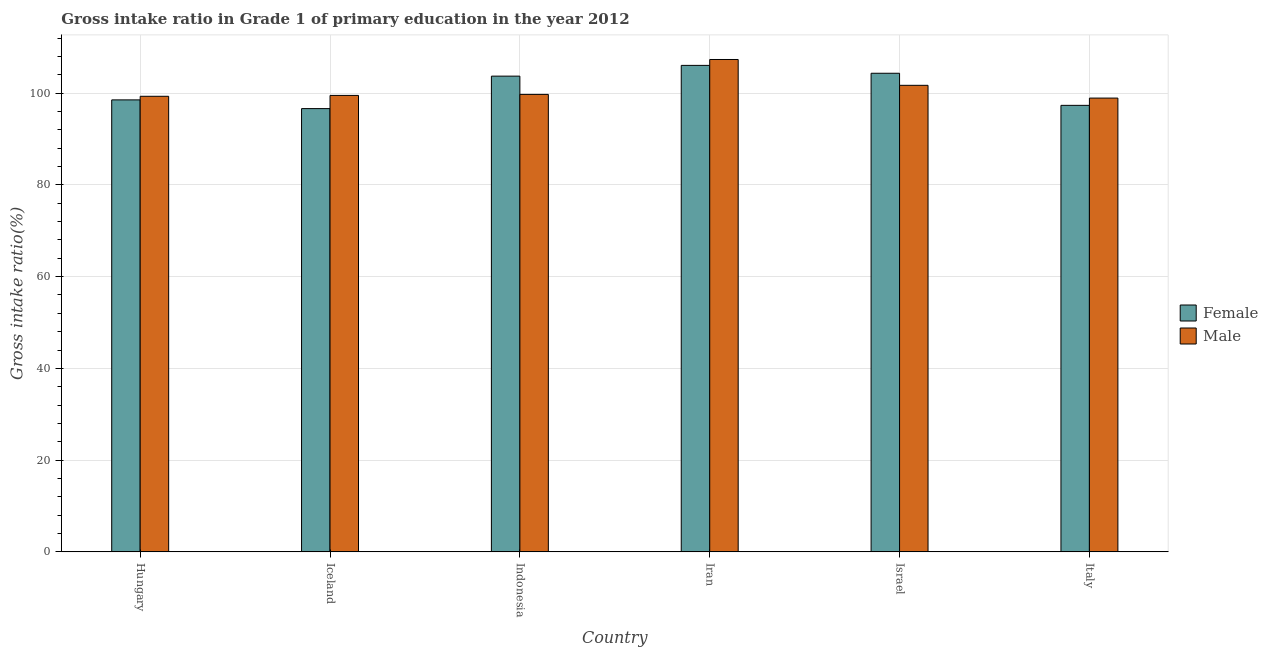How many different coloured bars are there?
Give a very brief answer. 2. Are the number of bars per tick equal to the number of legend labels?
Keep it short and to the point. Yes. How many bars are there on the 1st tick from the left?
Keep it short and to the point. 2. What is the gross intake ratio(male) in Indonesia?
Give a very brief answer. 99.73. Across all countries, what is the maximum gross intake ratio(female)?
Make the answer very short. 106.05. Across all countries, what is the minimum gross intake ratio(female)?
Make the answer very short. 96.63. In which country was the gross intake ratio(male) maximum?
Provide a succinct answer. Iran. In which country was the gross intake ratio(female) minimum?
Offer a very short reply. Iceland. What is the total gross intake ratio(male) in the graph?
Keep it short and to the point. 606.49. What is the difference between the gross intake ratio(male) in Iceland and that in Israel?
Give a very brief answer. -2.2. What is the difference between the gross intake ratio(male) in Italy and the gross intake ratio(female) in Iceland?
Offer a terse response. 2.29. What is the average gross intake ratio(female) per country?
Your answer should be compact. 101.1. What is the difference between the gross intake ratio(female) and gross intake ratio(male) in Hungary?
Ensure brevity in your answer.  -0.78. What is the ratio of the gross intake ratio(female) in Hungary to that in Italy?
Provide a short and direct response. 1.01. Is the gross intake ratio(male) in Hungary less than that in Italy?
Your answer should be compact. No. What is the difference between the highest and the second highest gross intake ratio(female)?
Keep it short and to the point. 1.72. What is the difference between the highest and the lowest gross intake ratio(female)?
Your answer should be very brief. 9.42. In how many countries, is the gross intake ratio(male) greater than the average gross intake ratio(male) taken over all countries?
Your response must be concise. 2. Is the sum of the gross intake ratio(male) in Hungary and Israel greater than the maximum gross intake ratio(female) across all countries?
Offer a terse response. Yes. How many bars are there?
Ensure brevity in your answer.  12. What is the difference between two consecutive major ticks on the Y-axis?
Your response must be concise. 20. Does the graph contain grids?
Give a very brief answer. Yes. Where does the legend appear in the graph?
Your answer should be compact. Center right. How many legend labels are there?
Ensure brevity in your answer.  2. How are the legend labels stacked?
Make the answer very short. Vertical. What is the title of the graph?
Give a very brief answer. Gross intake ratio in Grade 1 of primary education in the year 2012. What is the label or title of the X-axis?
Your answer should be very brief. Country. What is the label or title of the Y-axis?
Keep it short and to the point. Gross intake ratio(%). What is the Gross intake ratio(%) of Female in Hungary?
Your response must be concise. 98.53. What is the Gross intake ratio(%) of Male in Hungary?
Make the answer very short. 99.31. What is the Gross intake ratio(%) in Female in Iceland?
Provide a succinct answer. 96.63. What is the Gross intake ratio(%) of Male in Iceland?
Offer a terse response. 99.5. What is the Gross intake ratio(%) in Female in Indonesia?
Provide a succinct answer. 103.7. What is the Gross intake ratio(%) in Male in Indonesia?
Make the answer very short. 99.73. What is the Gross intake ratio(%) in Female in Iran?
Make the answer very short. 106.05. What is the Gross intake ratio(%) in Male in Iran?
Your answer should be compact. 107.33. What is the Gross intake ratio(%) of Female in Israel?
Keep it short and to the point. 104.33. What is the Gross intake ratio(%) of Male in Israel?
Offer a terse response. 101.7. What is the Gross intake ratio(%) in Female in Italy?
Provide a short and direct response. 97.34. What is the Gross intake ratio(%) in Male in Italy?
Offer a very short reply. 98.92. Across all countries, what is the maximum Gross intake ratio(%) in Female?
Offer a terse response. 106.05. Across all countries, what is the maximum Gross intake ratio(%) in Male?
Offer a terse response. 107.33. Across all countries, what is the minimum Gross intake ratio(%) of Female?
Make the answer very short. 96.63. Across all countries, what is the minimum Gross intake ratio(%) of Male?
Provide a short and direct response. 98.92. What is the total Gross intake ratio(%) of Female in the graph?
Your response must be concise. 606.57. What is the total Gross intake ratio(%) in Male in the graph?
Keep it short and to the point. 606.49. What is the difference between the Gross intake ratio(%) of Female in Hungary and that in Iceland?
Make the answer very short. 1.9. What is the difference between the Gross intake ratio(%) in Male in Hungary and that in Iceland?
Offer a very short reply. -0.19. What is the difference between the Gross intake ratio(%) in Female in Hungary and that in Indonesia?
Provide a short and direct response. -5.18. What is the difference between the Gross intake ratio(%) of Male in Hungary and that in Indonesia?
Offer a terse response. -0.41. What is the difference between the Gross intake ratio(%) of Female in Hungary and that in Iran?
Offer a very short reply. -7.52. What is the difference between the Gross intake ratio(%) in Male in Hungary and that in Iran?
Provide a succinct answer. -8.02. What is the difference between the Gross intake ratio(%) of Female in Hungary and that in Israel?
Give a very brief answer. -5.8. What is the difference between the Gross intake ratio(%) of Male in Hungary and that in Israel?
Offer a terse response. -2.39. What is the difference between the Gross intake ratio(%) in Female in Hungary and that in Italy?
Make the answer very short. 1.19. What is the difference between the Gross intake ratio(%) in Male in Hungary and that in Italy?
Your answer should be compact. 0.39. What is the difference between the Gross intake ratio(%) in Female in Iceland and that in Indonesia?
Provide a succinct answer. -7.08. What is the difference between the Gross intake ratio(%) in Male in Iceland and that in Indonesia?
Give a very brief answer. -0.22. What is the difference between the Gross intake ratio(%) of Female in Iceland and that in Iran?
Your answer should be very brief. -9.42. What is the difference between the Gross intake ratio(%) of Male in Iceland and that in Iran?
Offer a very short reply. -7.83. What is the difference between the Gross intake ratio(%) in Female in Iceland and that in Israel?
Your response must be concise. -7.7. What is the difference between the Gross intake ratio(%) in Male in Iceland and that in Israel?
Offer a very short reply. -2.2. What is the difference between the Gross intake ratio(%) of Female in Iceland and that in Italy?
Your answer should be very brief. -0.71. What is the difference between the Gross intake ratio(%) in Male in Iceland and that in Italy?
Your answer should be compact. 0.59. What is the difference between the Gross intake ratio(%) of Female in Indonesia and that in Iran?
Make the answer very short. -2.34. What is the difference between the Gross intake ratio(%) in Male in Indonesia and that in Iran?
Your response must be concise. -7.61. What is the difference between the Gross intake ratio(%) in Female in Indonesia and that in Israel?
Offer a terse response. -0.63. What is the difference between the Gross intake ratio(%) in Male in Indonesia and that in Israel?
Your answer should be very brief. -1.98. What is the difference between the Gross intake ratio(%) of Female in Indonesia and that in Italy?
Make the answer very short. 6.37. What is the difference between the Gross intake ratio(%) of Male in Indonesia and that in Italy?
Your answer should be compact. 0.81. What is the difference between the Gross intake ratio(%) of Female in Iran and that in Israel?
Give a very brief answer. 1.72. What is the difference between the Gross intake ratio(%) of Male in Iran and that in Israel?
Offer a very short reply. 5.63. What is the difference between the Gross intake ratio(%) of Female in Iran and that in Italy?
Provide a short and direct response. 8.71. What is the difference between the Gross intake ratio(%) in Male in Iran and that in Italy?
Make the answer very short. 8.41. What is the difference between the Gross intake ratio(%) in Female in Israel and that in Italy?
Your answer should be very brief. 7. What is the difference between the Gross intake ratio(%) in Male in Israel and that in Italy?
Keep it short and to the point. 2.78. What is the difference between the Gross intake ratio(%) in Female in Hungary and the Gross intake ratio(%) in Male in Iceland?
Your answer should be very brief. -0.98. What is the difference between the Gross intake ratio(%) of Female in Hungary and the Gross intake ratio(%) of Male in Indonesia?
Your answer should be very brief. -1.2. What is the difference between the Gross intake ratio(%) of Female in Hungary and the Gross intake ratio(%) of Male in Iran?
Your answer should be very brief. -8.8. What is the difference between the Gross intake ratio(%) in Female in Hungary and the Gross intake ratio(%) in Male in Israel?
Give a very brief answer. -3.17. What is the difference between the Gross intake ratio(%) of Female in Hungary and the Gross intake ratio(%) of Male in Italy?
Keep it short and to the point. -0.39. What is the difference between the Gross intake ratio(%) of Female in Iceland and the Gross intake ratio(%) of Male in Indonesia?
Ensure brevity in your answer.  -3.1. What is the difference between the Gross intake ratio(%) in Female in Iceland and the Gross intake ratio(%) in Male in Iran?
Ensure brevity in your answer.  -10.7. What is the difference between the Gross intake ratio(%) of Female in Iceland and the Gross intake ratio(%) of Male in Israel?
Keep it short and to the point. -5.07. What is the difference between the Gross intake ratio(%) of Female in Iceland and the Gross intake ratio(%) of Male in Italy?
Your response must be concise. -2.29. What is the difference between the Gross intake ratio(%) in Female in Indonesia and the Gross intake ratio(%) in Male in Iran?
Offer a terse response. -3.63. What is the difference between the Gross intake ratio(%) in Female in Indonesia and the Gross intake ratio(%) in Male in Israel?
Offer a very short reply. 2. What is the difference between the Gross intake ratio(%) in Female in Indonesia and the Gross intake ratio(%) in Male in Italy?
Offer a very short reply. 4.79. What is the difference between the Gross intake ratio(%) in Female in Iran and the Gross intake ratio(%) in Male in Israel?
Give a very brief answer. 4.35. What is the difference between the Gross intake ratio(%) of Female in Iran and the Gross intake ratio(%) of Male in Italy?
Provide a succinct answer. 7.13. What is the difference between the Gross intake ratio(%) of Female in Israel and the Gross intake ratio(%) of Male in Italy?
Keep it short and to the point. 5.41. What is the average Gross intake ratio(%) of Female per country?
Keep it short and to the point. 101.1. What is the average Gross intake ratio(%) in Male per country?
Give a very brief answer. 101.08. What is the difference between the Gross intake ratio(%) of Female and Gross intake ratio(%) of Male in Hungary?
Your response must be concise. -0.78. What is the difference between the Gross intake ratio(%) in Female and Gross intake ratio(%) in Male in Iceland?
Offer a very short reply. -2.88. What is the difference between the Gross intake ratio(%) of Female and Gross intake ratio(%) of Male in Indonesia?
Your answer should be very brief. 3.98. What is the difference between the Gross intake ratio(%) in Female and Gross intake ratio(%) in Male in Iran?
Give a very brief answer. -1.28. What is the difference between the Gross intake ratio(%) of Female and Gross intake ratio(%) of Male in Israel?
Make the answer very short. 2.63. What is the difference between the Gross intake ratio(%) in Female and Gross intake ratio(%) in Male in Italy?
Your response must be concise. -1.58. What is the ratio of the Gross intake ratio(%) in Female in Hungary to that in Iceland?
Ensure brevity in your answer.  1.02. What is the ratio of the Gross intake ratio(%) of Male in Hungary to that in Iceland?
Provide a short and direct response. 1. What is the ratio of the Gross intake ratio(%) in Female in Hungary to that in Indonesia?
Give a very brief answer. 0.95. What is the ratio of the Gross intake ratio(%) of Female in Hungary to that in Iran?
Your answer should be very brief. 0.93. What is the ratio of the Gross intake ratio(%) in Male in Hungary to that in Iran?
Provide a short and direct response. 0.93. What is the ratio of the Gross intake ratio(%) in Male in Hungary to that in Israel?
Provide a succinct answer. 0.98. What is the ratio of the Gross intake ratio(%) of Female in Hungary to that in Italy?
Offer a very short reply. 1.01. What is the ratio of the Gross intake ratio(%) of Female in Iceland to that in Indonesia?
Ensure brevity in your answer.  0.93. What is the ratio of the Gross intake ratio(%) of Male in Iceland to that in Indonesia?
Keep it short and to the point. 1. What is the ratio of the Gross intake ratio(%) in Female in Iceland to that in Iran?
Ensure brevity in your answer.  0.91. What is the ratio of the Gross intake ratio(%) of Male in Iceland to that in Iran?
Provide a short and direct response. 0.93. What is the ratio of the Gross intake ratio(%) in Female in Iceland to that in Israel?
Provide a short and direct response. 0.93. What is the ratio of the Gross intake ratio(%) in Male in Iceland to that in Israel?
Provide a short and direct response. 0.98. What is the ratio of the Gross intake ratio(%) of Male in Iceland to that in Italy?
Keep it short and to the point. 1.01. What is the ratio of the Gross intake ratio(%) of Female in Indonesia to that in Iran?
Your answer should be compact. 0.98. What is the ratio of the Gross intake ratio(%) in Male in Indonesia to that in Iran?
Keep it short and to the point. 0.93. What is the ratio of the Gross intake ratio(%) in Female in Indonesia to that in Israel?
Keep it short and to the point. 0.99. What is the ratio of the Gross intake ratio(%) of Male in Indonesia to that in Israel?
Offer a terse response. 0.98. What is the ratio of the Gross intake ratio(%) in Female in Indonesia to that in Italy?
Offer a terse response. 1.07. What is the ratio of the Gross intake ratio(%) in Male in Indonesia to that in Italy?
Provide a short and direct response. 1.01. What is the ratio of the Gross intake ratio(%) of Female in Iran to that in Israel?
Ensure brevity in your answer.  1.02. What is the ratio of the Gross intake ratio(%) in Male in Iran to that in Israel?
Offer a terse response. 1.06. What is the ratio of the Gross intake ratio(%) in Female in Iran to that in Italy?
Offer a very short reply. 1.09. What is the ratio of the Gross intake ratio(%) of Male in Iran to that in Italy?
Provide a short and direct response. 1.09. What is the ratio of the Gross intake ratio(%) in Female in Israel to that in Italy?
Offer a very short reply. 1.07. What is the ratio of the Gross intake ratio(%) of Male in Israel to that in Italy?
Provide a succinct answer. 1.03. What is the difference between the highest and the second highest Gross intake ratio(%) of Female?
Offer a terse response. 1.72. What is the difference between the highest and the second highest Gross intake ratio(%) in Male?
Provide a short and direct response. 5.63. What is the difference between the highest and the lowest Gross intake ratio(%) of Female?
Keep it short and to the point. 9.42. What is the difference between the highest and the lowest Gross intake ratio(%) in Male?
Ensure brevity in your answer.  8.41. 